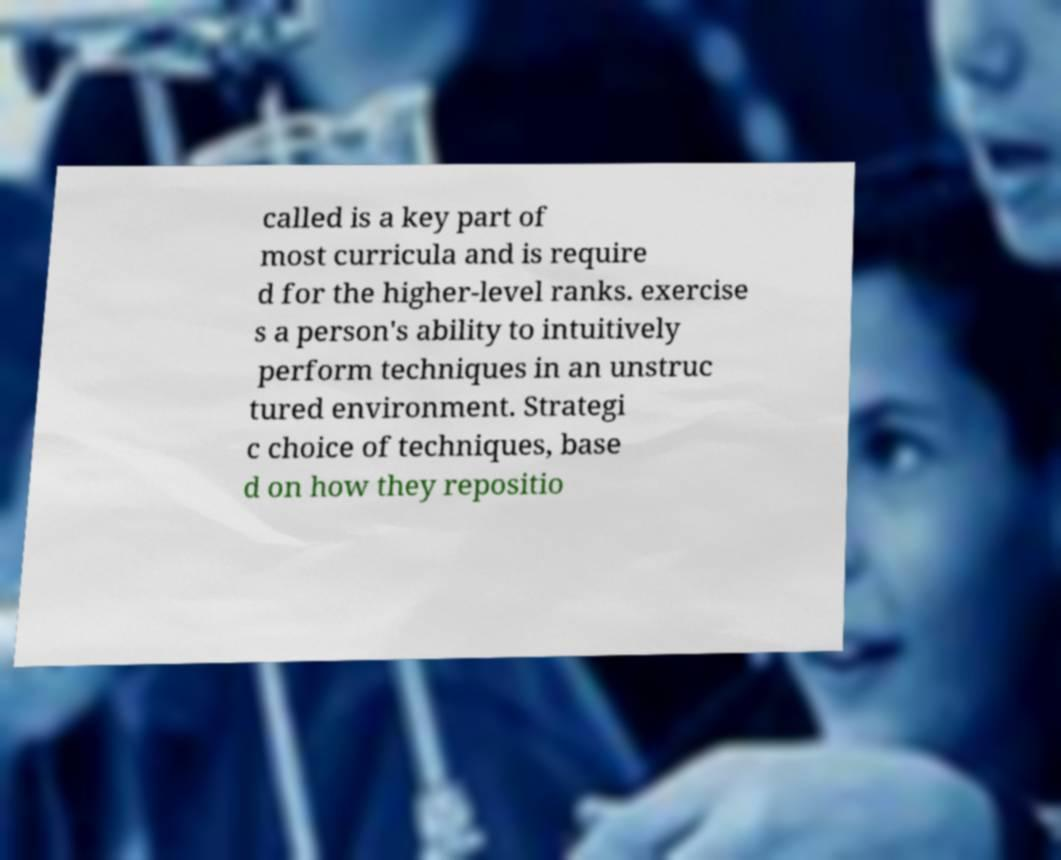Could you extract and type out the text from this image? called is a key part of most curricula and is require d for the higher-level ranks. exercise s a person's ability to intuitively perform techniques in an unstruc tured environment. Strategi c choice of techniques, base d on how they repositio 